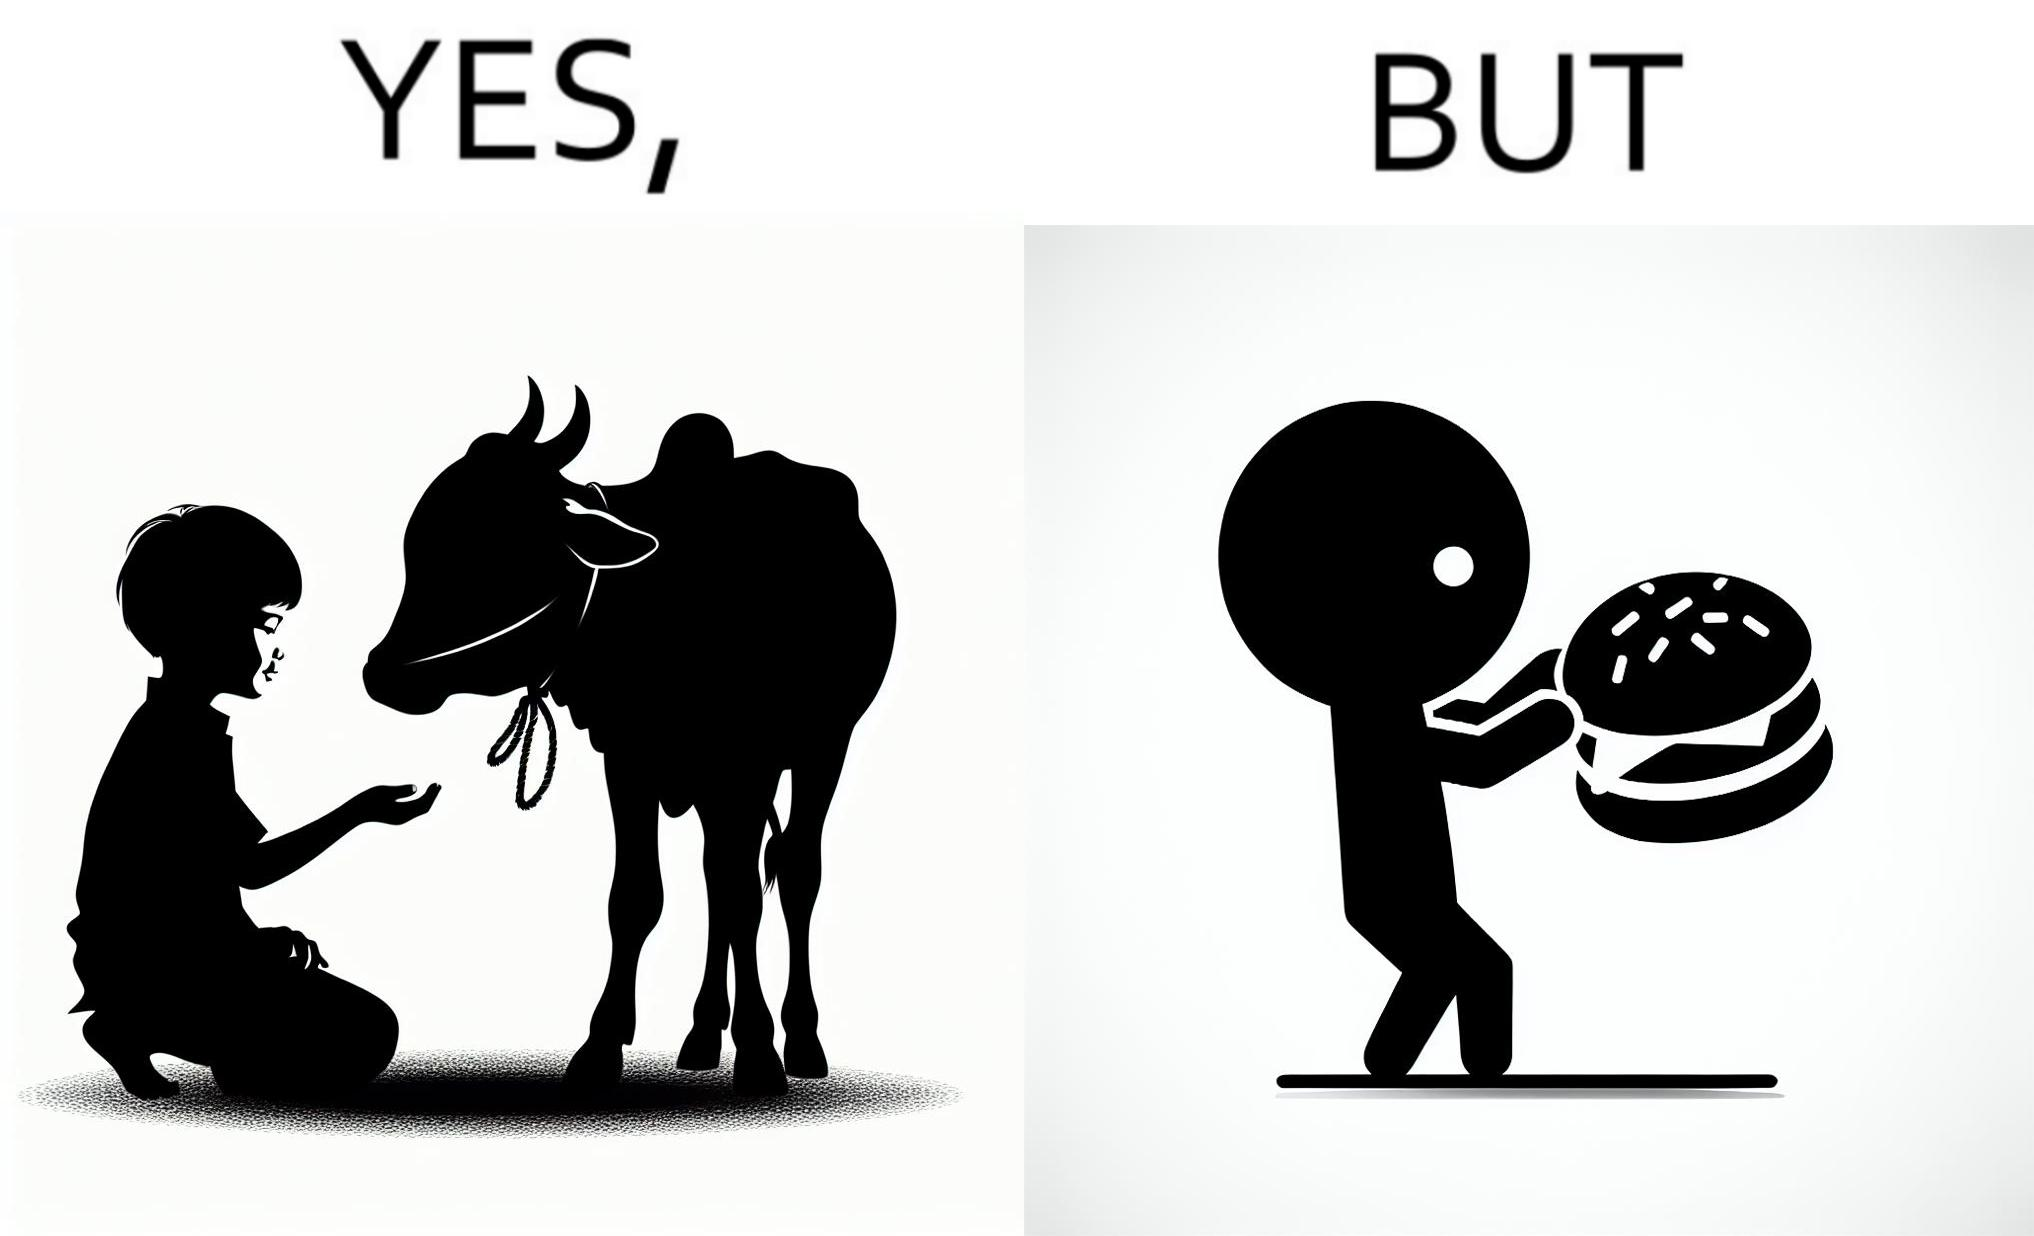What does this image depict? The irony is that the boy is petting the cow to show that he cares about the animal, but then he also eats hamburgers made from the same cows 